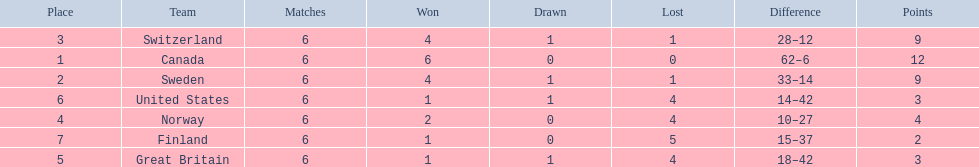Which are the two countries? Switzerland, Great Britain. What were the point totals for each of these countries? 9, 3. Of these point totals, which is better? 9. Which country earned this point total? Switzerland. 